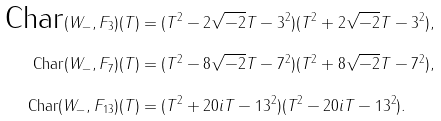Convert formula to latex. <formula><loc_0><loc_0><loc_500><loc_500>\text {Char} ( W _ { - } , F _ { 3 } ) ( T ) & = ( T ^ { 2 } - 2 \sqrt { - 2 } T - 3 ^ { 2 } ) ( T ^ { 2 } + 2 \sqrt { - 2 } T - 3 ^ { 2 } ) , \\ \text {Char} ( W _ { - } , F _ { 7 } ) ( T ) & = ( T ^ { 2 } - 8 \sqrt { - 2 } T - 7 ^ { 2 } ) ( T ^ { 2 } + 8 \sqrt { - 2 } T - 7 ^ { 2 } ) , \\ \text {Char} ( W _ { - } , F _ { 1 3 } ) ( T ) & = ( T ^ { 2 } + 2 0 i T - 1 3 ^ { 2 } ) ( T ^ { 2 } - 2 0 i T - 1 3 ^ { 2 } ) . \\</formula> 